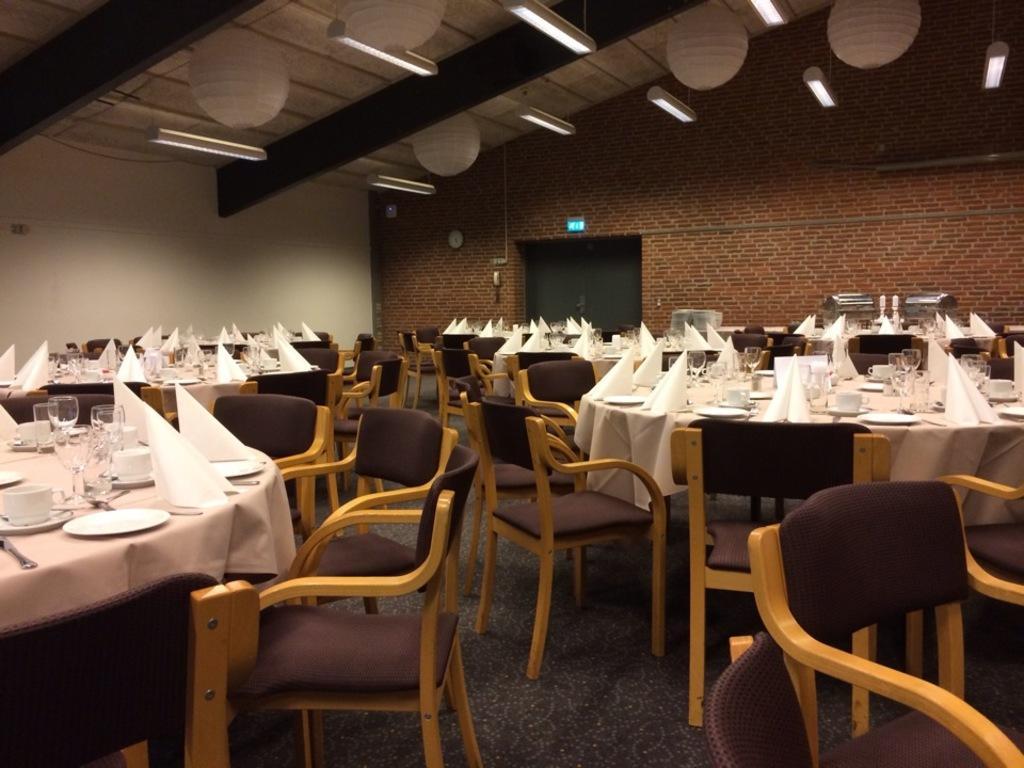Describe this image in one or two sentences. In this picture we can see the inside view of the hotel. In that we can see many tables and chairs. On the right table we can see the plates, glasses, cup, saucer and other objects. In the background wall clock near to the exit door. At the top we can see the tube lights which is hanging from the roof. 